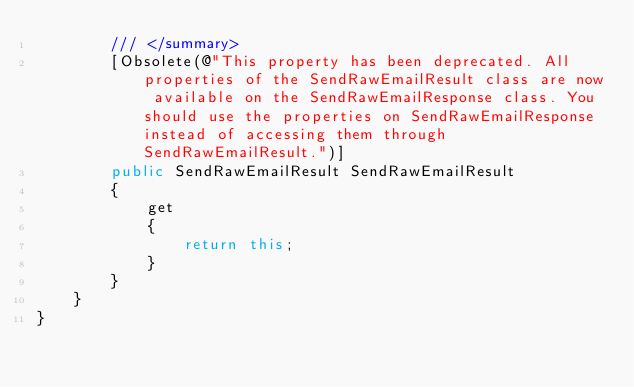<code> <loc_0><loc_0><loc_500><loc_500><_C#_>        /// </summary>
        [Obsolete(@"This property has been deprecated. All properties of the SendRawEmailResult class are now available on the SendRawEmailResponse class. You should use the properties on SendRawEmailResponse instead of accessing them through SendRawEmailResult.")]
        public SendRawEmailResult SendRawEmailResult
        {
            get
            {
                return this;
            }
        }
    }
}</code> 